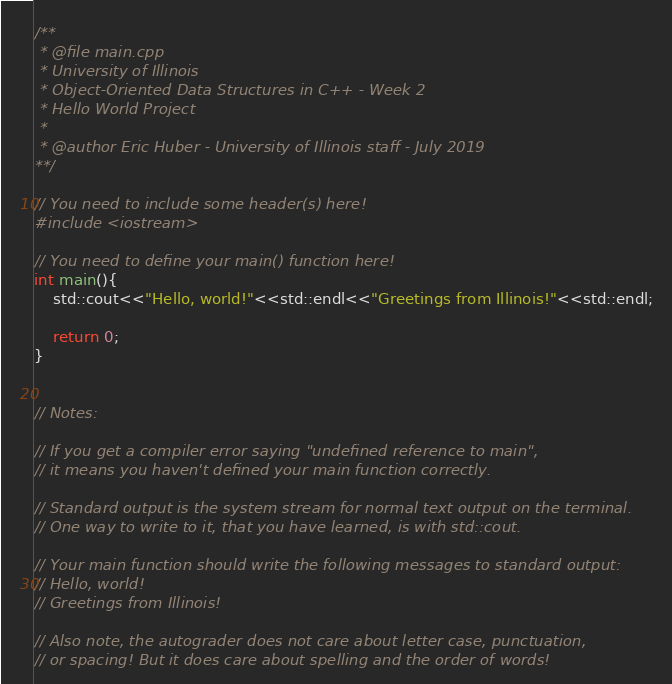<code> <loc_0><loc_0><loc_500><loc_500><_C++_>/**
 * @file main.cpp
 * University of Illinois
 * Object-Oriented Data Structures in C++ - Week 2
 * Hello World Project
 *
 * @author Eric Huber - University of Illinois staff - July 2019
**/

// You need to include some header(s) here!
#include <iostream>

// You need to define your main() function here!
int main(){
    std::cout<<"Hello, world!"<<std::endl<<"Greetings from Illinois!"<<std::endl;

    return 0;
}


// Notes:

// If you get a compiler error saying "undefined reference to main",
// it means you haven't defined your main function correctly.

// Standard output is the system stream for normal text output on the terminal.
// One way to write to it, that you have learned, is with std::cout.

// Your main function should write the following messages to standard output:
// Hello, world!
// Greetings from Illinois!

// Also note, the autograder does not care about letter case, punctuation,
// or spacing! But it does care about spelling and the order of words!

</code> 